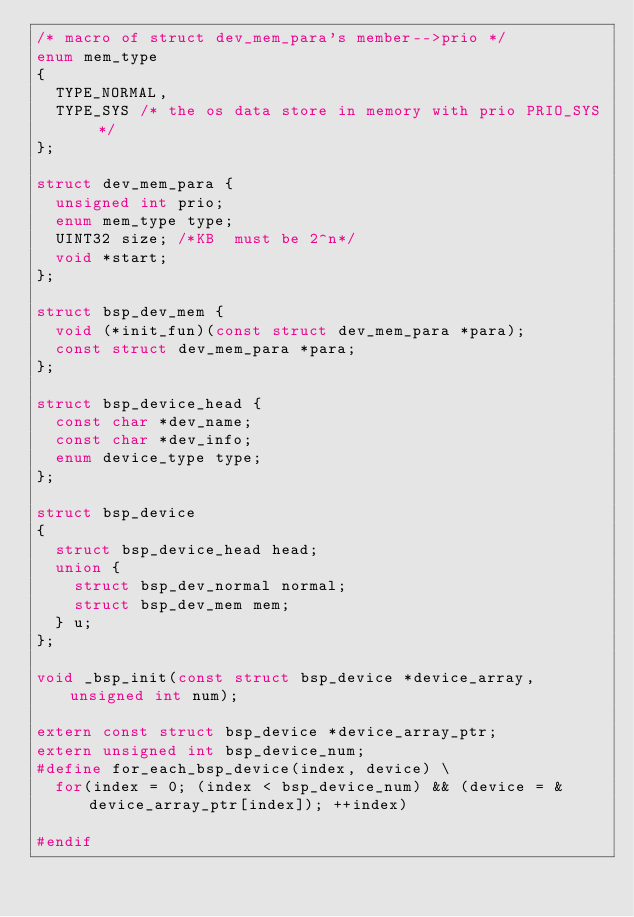Convert code to text. <code><loc_0><loc_0><loc_500><loc_500><_C_>/* macro of struct dev_mem_para's member-->prio */
enum mem_type
{
	TYPE_NORMAL,
	TYPE_SYS /* the os data store in memory with prio PRIO_SYS */
};

struct dev_mem_para {
	unsigned int prio;
	enum mem_type type;
	UINT32 size; /*KB  must be 2^n*/
	void *start;
};

struct bsp_dev_mem {
	void (*init_fun)(const struct dev_mem_para *para);
	const struct dev_mem_para *para;
};

struct bsp_device_head {
	const char *dev_name;
	const char *dev_info;
	enum device_type type;
};

struct bsp_device
{
	struct bsp_device_head head;
	union {
		struct bsp_dev_normal normal;
		struct bsp_dev_mem mem;
	} u;
};

void _bsp_init(const struct bsp_device *device_array, unsigned int num);

extern const struct bsp_device *device_array_ptr;
extern unsigned int bsp_device_num;
#define for_each_bsp_device(index, device) \
	for(index = 0; (index < bsp_device_num) && (device = &device_array_ptr[index]); ++index)

#endif
</code> 